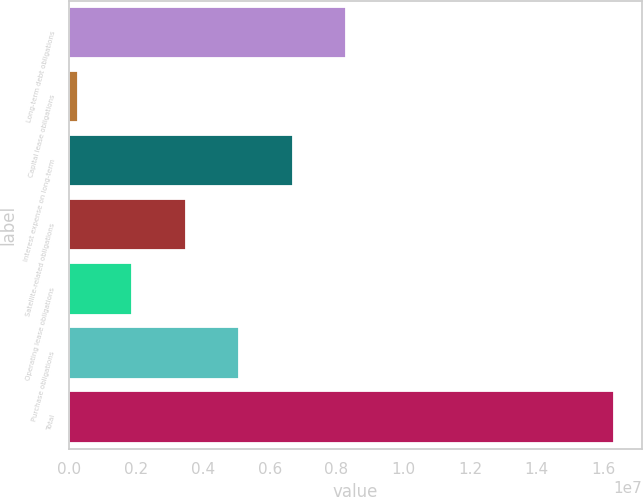<chart> <loc_0><loc_0><loc_500><loc_500><bar_chart><fcel>Long-term debt obligations<fcel>Capital lease obligations<fcel>Interest expense on long-term<fcel>Satellite-related obligations<fcel>Operating lease obligations<fcel>Purchase obligations<fcel>Total<nl><fcel>8.29867e+06<fcel>271908<fcel>6.69332e+06<fcel>3.48261e+06<fcel>1.87726e+06<fcel>5.08797e+06<fcel>1.63254e+07<nl></chart> 